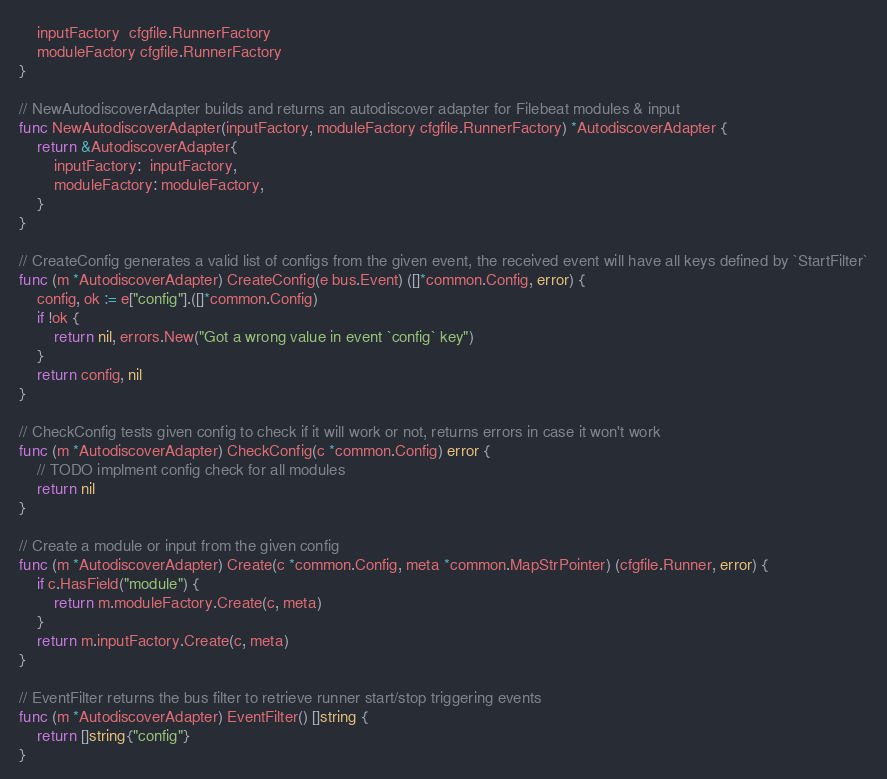Convert code to text. <code><loc_0><loc_0><loc_500><loc_500><_Go_>	inputFactory  cfgfile.RunnerFactory
	moduleFactory cfgfile.RunnerFactory
}

// NewAutodiscoverAdapter builds and returns an autodiscover adapter for Filebeat modules & input
func NewAutodiscoverAdapter(inputFactory, moduleFactory cfgfile.RunnerFactory) *AutodiscoverAdapter {
	return &AutodiscoverAdapter{
		inputFactory:  inputFactory,
		moduleFactory: moduleFactory,
	}
}

// CreateConfig generates a valid list of configs from the given event, the received event will have all keys defined by `StartFilter`
func (m *AutodiscoverAdapter) CreateConfig(e bus.Event) ([]*common.Config, error) {
	config, ok := e["config"].([]*common.Config)
	if !ok {
		return nil, errors.New("Got a wrong value in event `config` key")
	}
	return config, nil
}

// CheckConfig tests given config to check if it will work or not, returns errors in case it won't work
func (m *AutodiscoverAdapter) CheckConfig(c *common.Config) error {
	// TODO implment config check for all modules
	return nil
}

// Create a module or input from the given config
func (m *AutodiscoverAdapter) Create(c *common.Config, meta *common.MapStrPointer) (cfgfile.Runner, error) {
	if c.HasField("module") {
		return m.moduleFactory.Create(c, meta)
	}
	return m.inputFactory.Create(c, meta)
}

// EventFilter returns the bus filter to retrieve runner start/stop triggering events
func (m *AutodiscoverAdapter) EventFilter() []string {
	return []string{"config"}
}
</code> 